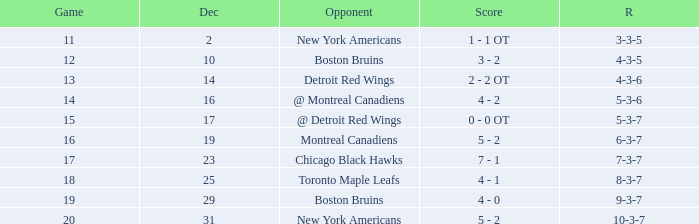Which December has a Record of 4-3-6? 14.0. 